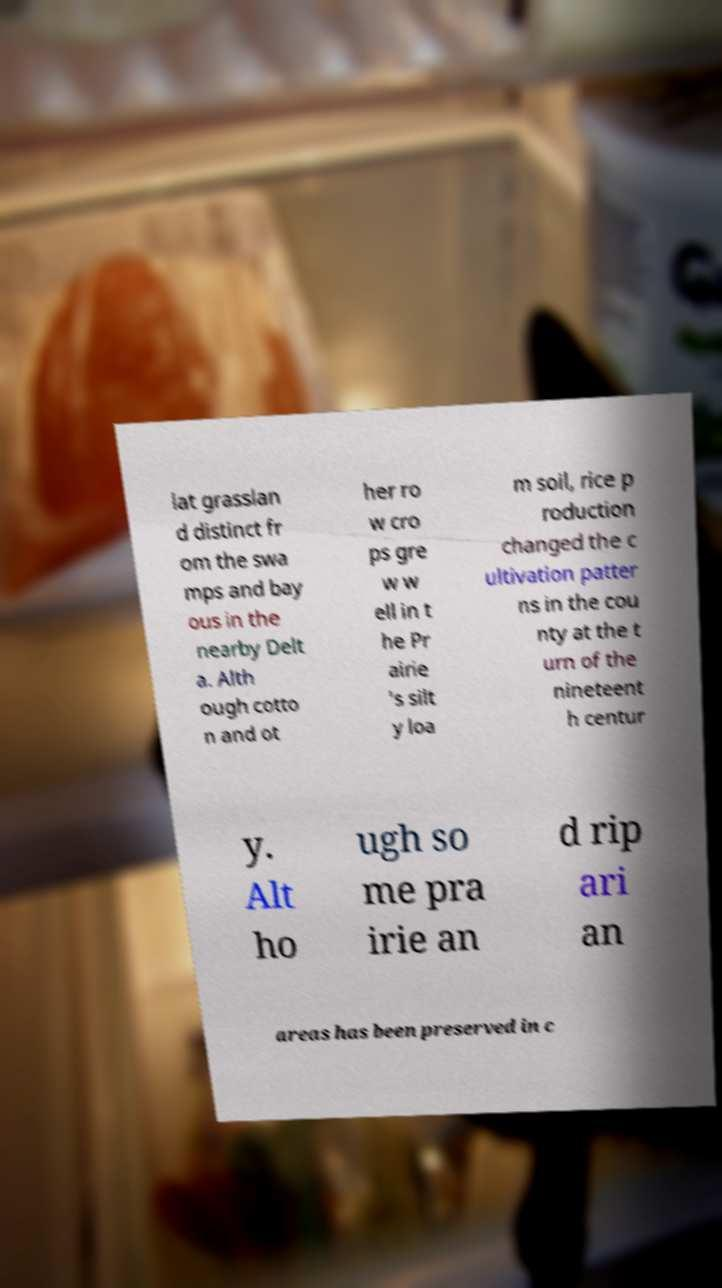For documentation purposes, I need the text within this image transcribed. Could you provide that? lat grasslan d distinct fr om the swa mps and bay ous in the nearby Delt a. Alth ough cotto n and ot her ro w cro ps gre w w ell in t he Pr airie 's silt y loa m soil, rice p roduction changed the c ultivation patter ns in the cou nty at the t urn of the nineteent h centur y. Alt ho ugh so me pra irie an d rip ari an areas has been preserved in c 